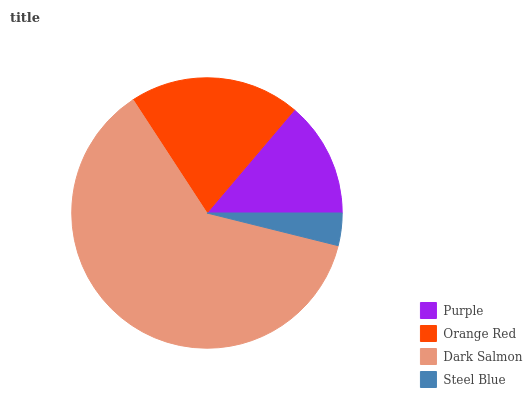Is Steel Blue the minimum?
Answer yes or no. Yes. Is Dark Salmon the maximum?
Answer yes or no. Yes. Is Orange Red the minimum?
Answer yes or no. No. Is Orange Red the maximum?
Answer yes or no. No. Is Orange Red greater than Purple?
Answer yes or no. Yes. Is Purple less than Orange Red?
Answer yes or no. Yes. Is Purple greater than Orange Red?
Answer yes or no. No. Is Orange Red less than Purple?
Answer yes or no. No. Is Orange Red the high median?
Answer yes or no. Yes. Is Purple the low median?
Answer yes or no. Yes. Is Steel Blue the high median?
Answer yes or no. No. Is Orange Red the low median?
Answer yes or no. No. 